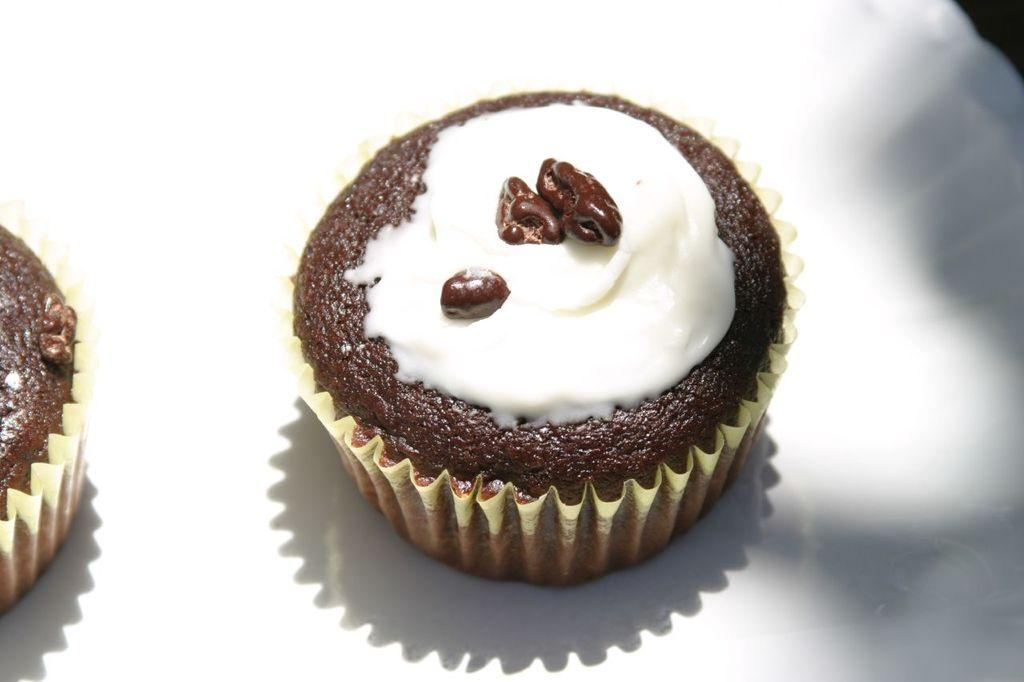What type of food can be seen in the image? There are muffins in the image. What color is the background of the image? The background of the image is white. What type of clover is growing in the aftermath of the event depicted in the image? There is no clover or event depicted in the image; it only shows muffins with a white background. 